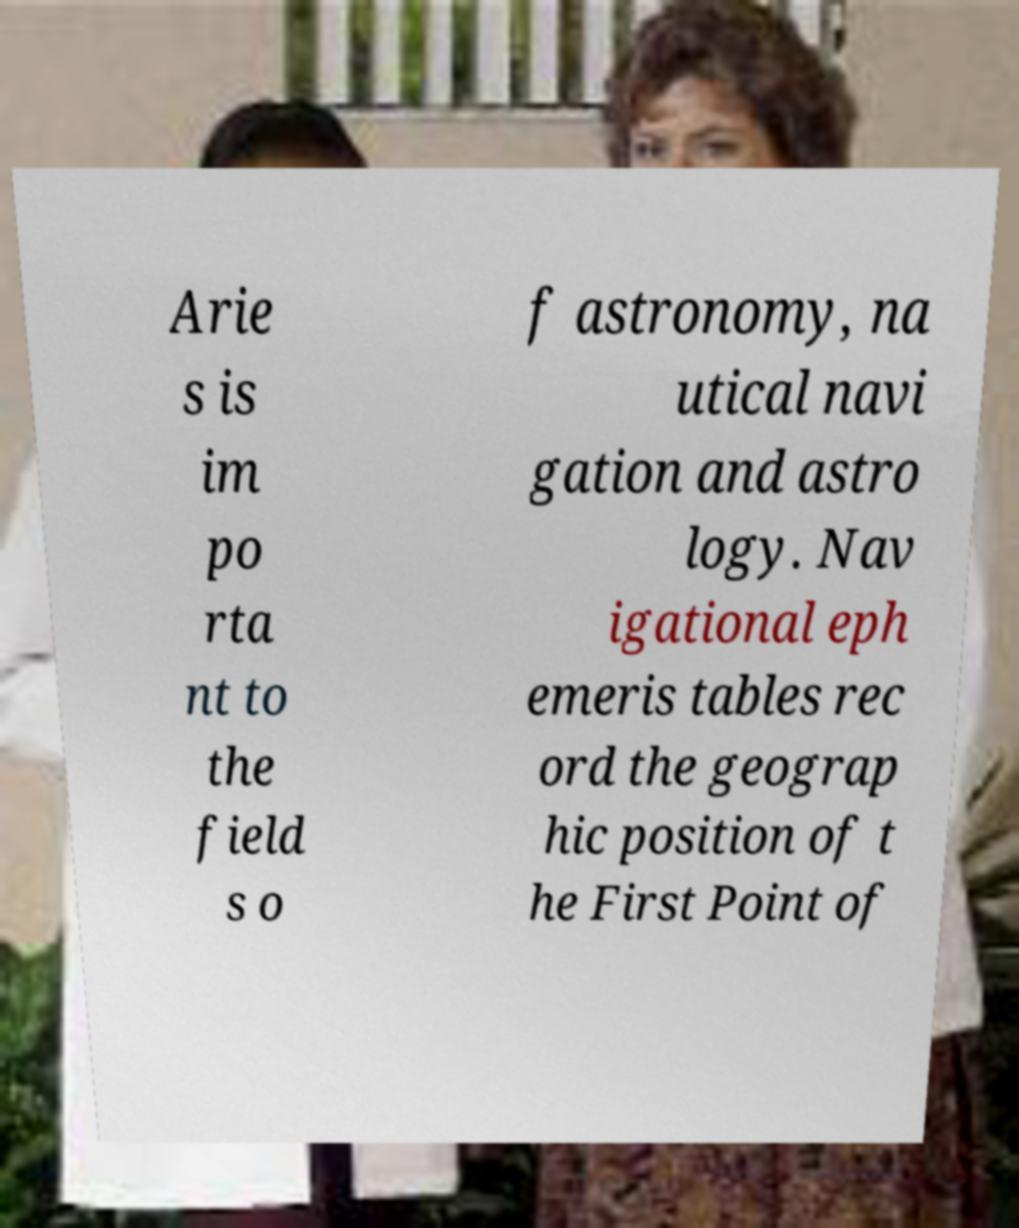What messages or text are displayed in this image? I need them in a readable, typed format. Arie s is im po rta nt to the field s o f astronomy, na utical navi gation and astro logy. Nav igational eph emeris tables rec ord the geograp hic position of t he First Point of 